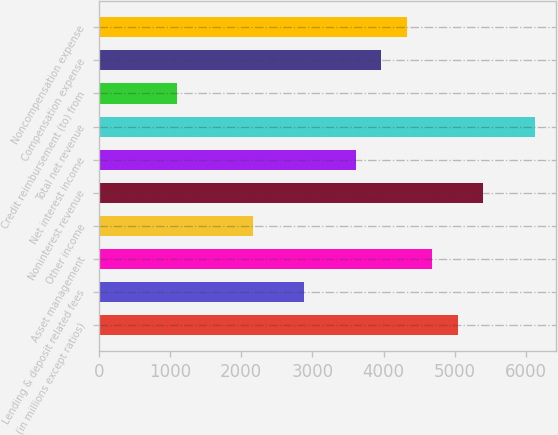<chart> <loc_0><loc_0><loc_500><loc_500><bar_chart><fcel>(in millions except ratios)<fcel>Lending & deposit related fees<fcel>Asset management<fcel>Other income<fcel>Noninterest revenue<fcel>Net interest income<fcel>Total net revenue<fcel>Credit reimbursement (to) from<fcel>Compensation expense<fcel>Noncompensation expense<nl><fcel>5045.2<fcel>2889.4<fcel>4685.9<fcel>2170.8<fcel>5404.5<fcel>3608<fcel>6123.1<fcel>1092.9<fcel>3967.3<fcel>4326.6<nl></chart> 